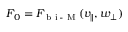<formula> <loc_0><loc_0><loc_500><loc_500>F _ { 0 } = F _ { b i - M } ( v _ { \| } , w _ { \perp } )</formula> 